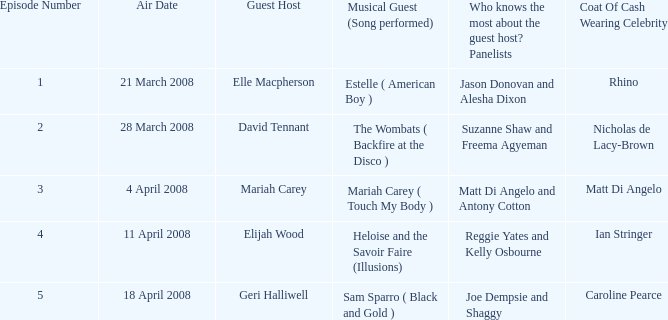Name the least number of episodes for the panelists of reggie yates and kelly osbourne 4.0. 